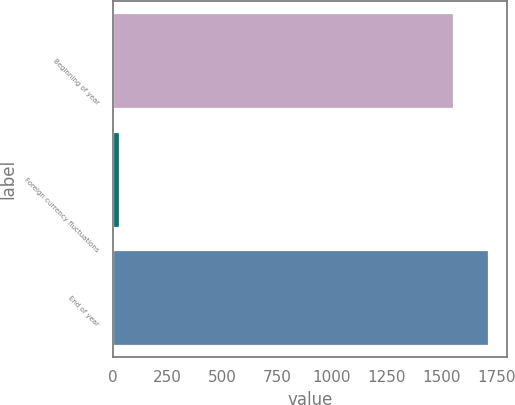<chart> <loc_0><loc_0><loc_500><loc_500><bar_chart><fcel>Beginning of year<fcel>Foreign currency fluctuations<fcel>End of year<nl><fcel>1551<fcel>25.8<fcel>1713.89<nl></chart> 